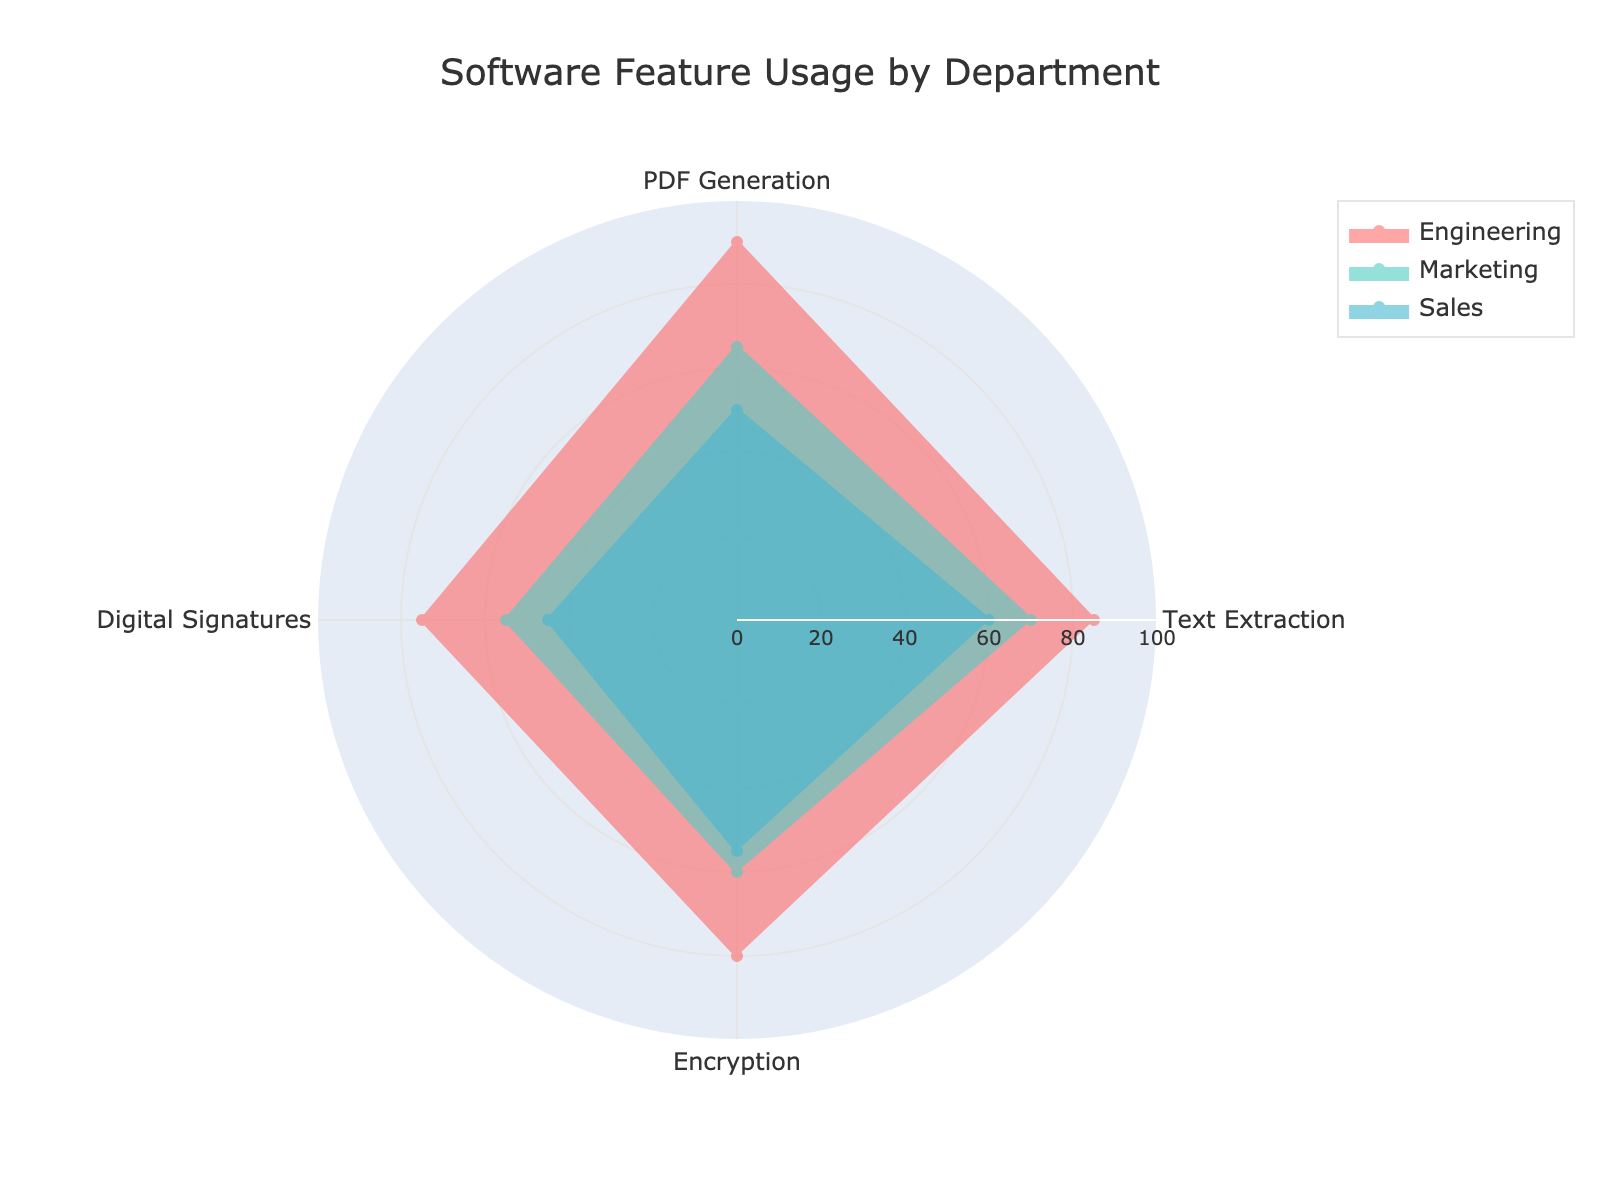What is the title of the radar chart? The title is typically found at the top center of the chart. In this case, it is clearly stated at the top.
Answer: Software Feature Usage by Department Which department has the highest score for PDF Generation? By identifying the highest point for PDF Generation, we can see which department's line reaches the farthest in that direction.
Answer: Engineering What is the average score of Engineering across all the features? Add up the scores of Engineering (85 + 90 + 75 + 80) and divide by the number of features (4). (85 + 90 + 75 + 80) / 4 = 82.5
Answer: 82.5 Which department shows the least usage of Digital Signatures? Compare the Digital Signatures scores for each department and identify the lowest one.
Answer: Human Resources How many departments are represented in the radar chart? The number of departments is counted along the legend or lines in the radar chart.
Answer: 3 Compare the Text Extraction scores of Engineering and Sales. Which is higher and by how much? Find the Text Extraction scores for both departments (Engineering: 85, Sales: 60) and calculate the difference. 85 - 60 = 25
Answer: Engineering by 25 What is the sum of PDF Generation and Encryption scores for Marketing? Add the PDF Generation score (65) and the Encryption score (60) for Marketing. 65 + 60 = 125
Answer: 125 Does Sales have a higher score in Text Extraction or Digital Signatures? Compare Sales scores in Text Extraction (60) and Digital Signatures (45) to see which is higher.
Answer: Text Extraction Which department has a more balanced usage of all features, based on the shape of the radar chart? A balanced usage would mean the department's shape is more circular, with scores closer to each other.
Answer: Engineering What is the total score for Human Resources across all features? Add up all the scores for Human Resources (55 + 45 + 35 + 40). 55 + 45 + 35 + 40 = 175
Answer: 175 